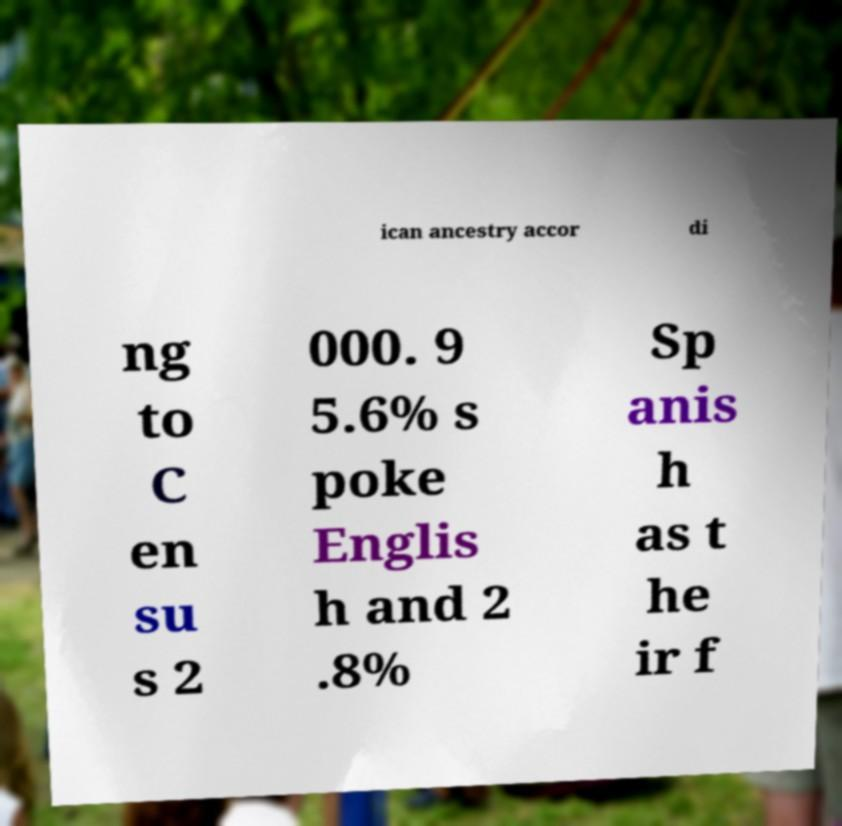For documentation purposes, I need the text within this image transcribed. Could you provide that? ican ancestry accor di ng to C en su s 2 000. 9 5.6% s poke Englis h and 2 .8% Sp anis h as t he ir f 